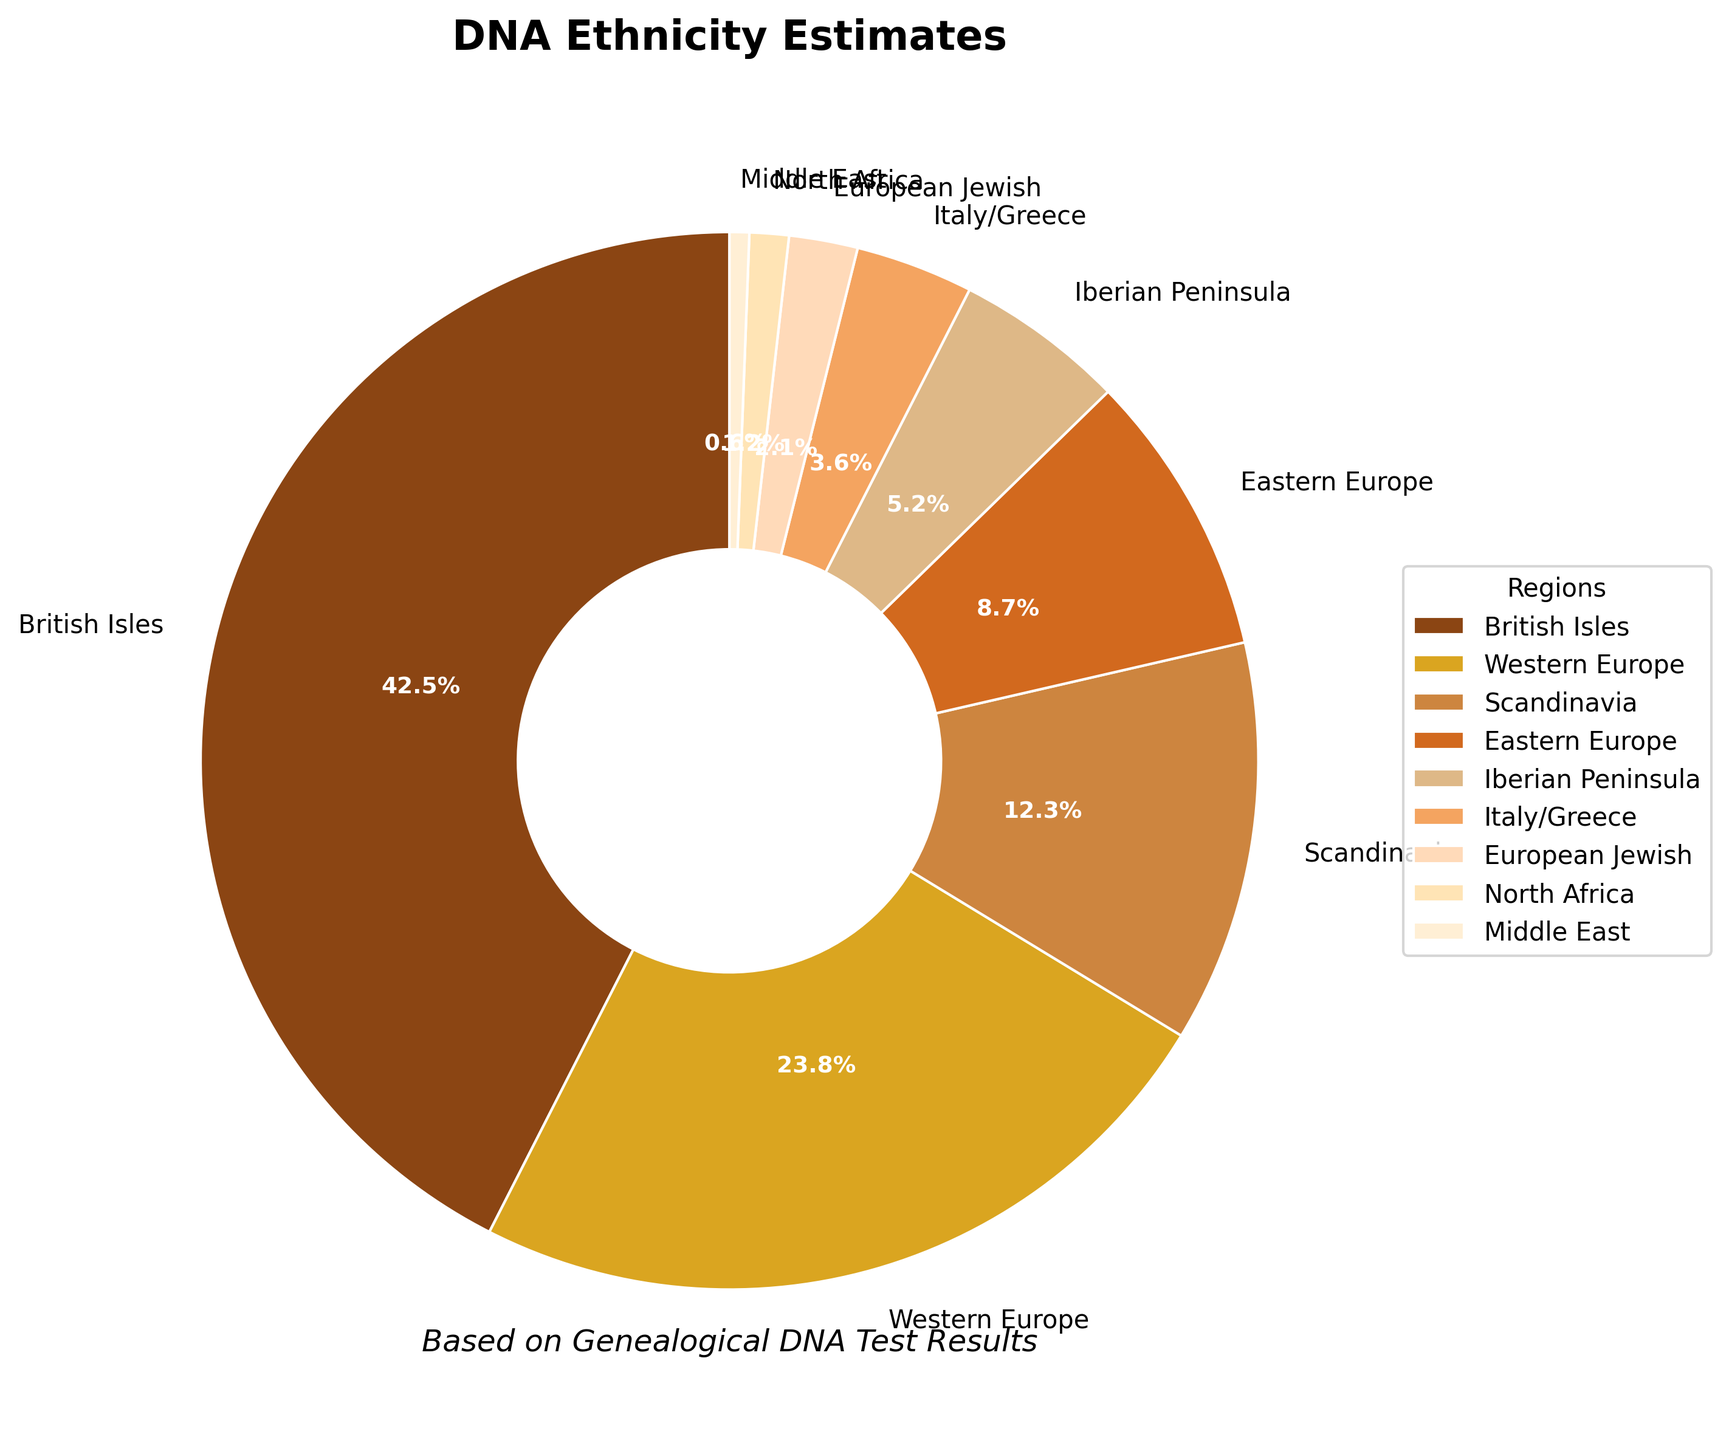Which region has the highest percentage? The region with the highest percentage would have the largest pie slice. According to the chart, British Isles has the largest slice, indicating it has the highest percentage.
Answer: British Isles What is the total percentage for Western Europe and Scandinavia? To find the total percentage for Western Europe and Scandinavia, add their individual percentages. Western Europe has 23.8% and Scandinavia has 12.3%. The sum is 23.8 + 12.3 = 36.1%.
Answer: 36.1% How much more is the percentage of British Isles compared to Eastern Europe? Subtract the percentage of Eastern Europe from that of British Isles. British Isles is 42.5% and Eastern Europe is 8.7%. The difference is 42.5 - 8.7 = 33.8%.
Answer: 33.8% What is the combined percentage for regions with less than 5% representation? Identify the regions with less than 5% and add their percentages. The regions are Iberian Peninsula (5.2%, but it's above 5%), Italy/Greece (3.6%), European Jewish (2.1%), North Africa (1.2%), and Middle East (0.6%). Their combined total is 3.6 + 2.1 + 1.2 + 0.6 = 7.5%.
Answer: 7.5% Which regions are visually represented by the smallest slices and what are their percentages? The smallest slices would visually appear smallest in the pie chart. The regions are North Africa and Middle East, represented by 1.2% and 0.6% respectively.
Answer: North Africa (1.2%), Middle East (0.6%) How does the percentage of Western Europe compare to that of the Iberian Peninsula? Western Europe has 23.8% and Iberian Peninsula has 5.2%. Western Europe has a higher percentage.
Answer: Western Europe is higher What is the average percentage of the regions representing more than 10%? Identify the regions with more than 10% (British Isles, Western Europe, Scandinavia) and calculate their average. Their percentages are 42.5%, 23.8%, and 12.3%. Add these values and divide by the number of regions: (42.5 + 23.8 + 12.3) / 3 = 26.2%.
Answer: 26.2% Do the British Isles and Western Europe combined represent more than half of the total percentage? Add the percentages for British Isles and Western Europe and see if the sum is greater than 50%. Their percentages are 42.5% and 23.8%. The combined total is 42.5 + 23.8 = 66.3%, which is more than half of the total (50%).
Answer: Yes 